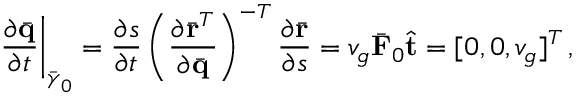Convert formula to latex. <formula><loc_0><loc_0><loc_500><loc_500>\frac { \partial \bar { q } } { \partial t } \right | _ { \bar { \gamma } _ { 0 } } = \frac { \partial s } { \partial t } \left ( \frac { \partial \bar { r } ^ { T } } { \partial \bar { q } } \right ) ^ { - T } \frac { \partial \bar { r } } { \partial s } = v _ { g } \bar { F } _ { 0 } \hat { t } = [ 0 , 0 , v _ { g } ] ^ { T } \, ,</formula> 